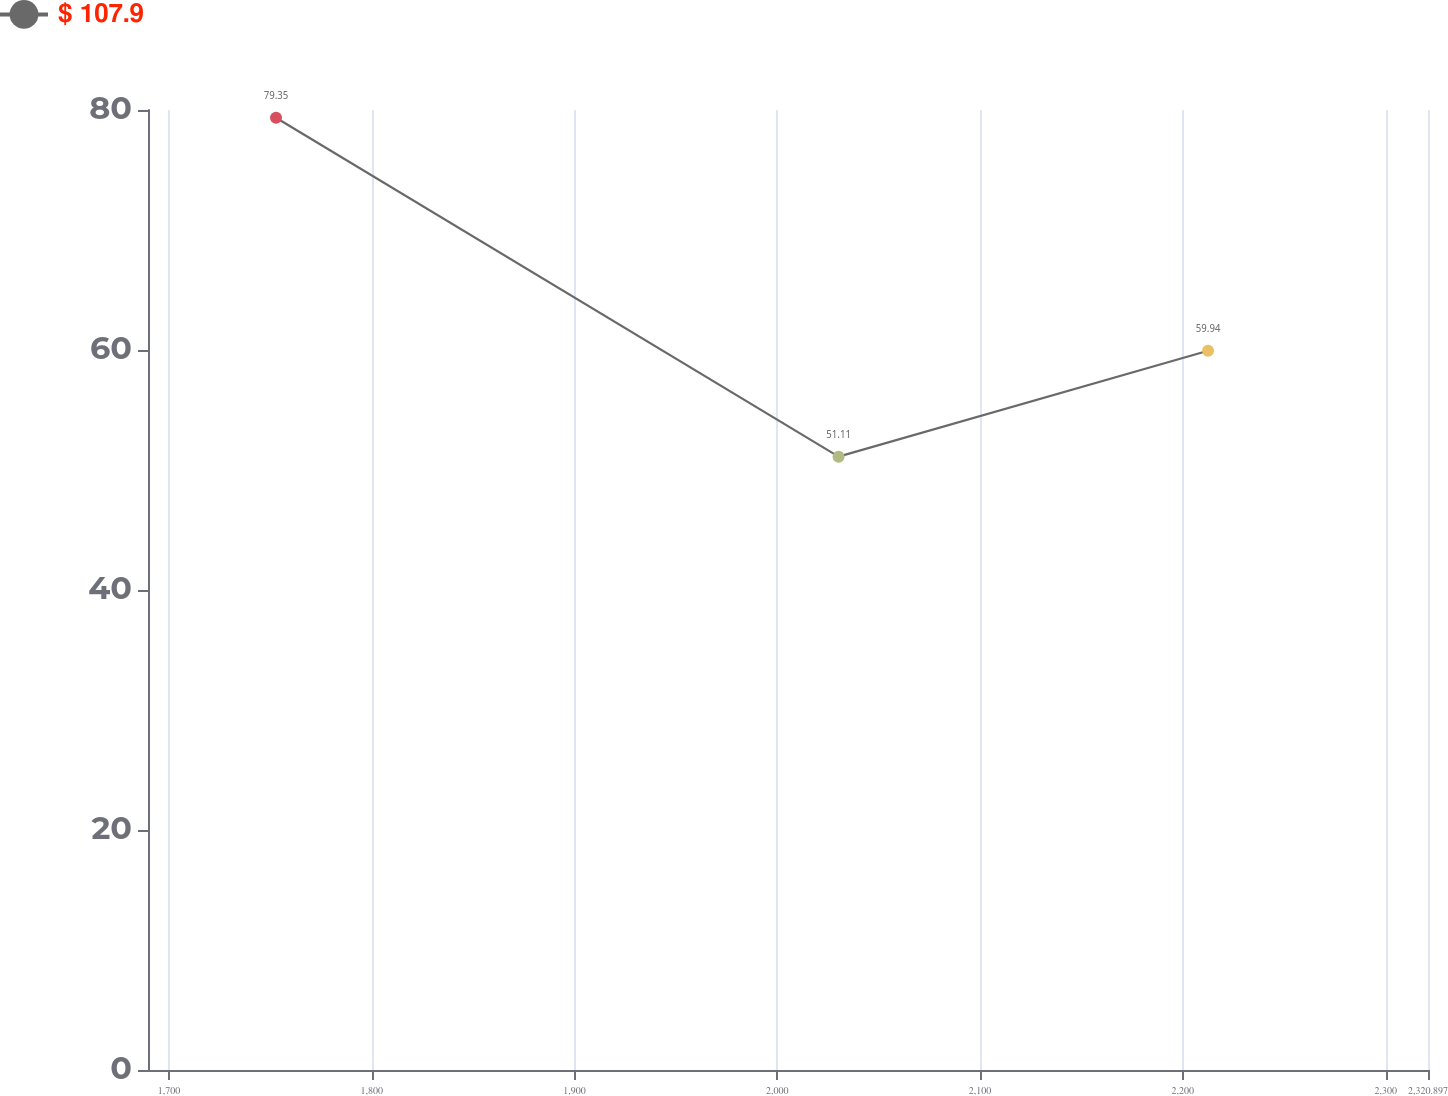<chart> <loc_0><loc_0><loc_500><loc_500><line_chart><ecel><fcel>$ 107.9<nl><fcel>1752.79<fcel>79.35<nl><fcel>2030.22<fcel>51.11<nl><fcel>2212.44<fcel>59.94<nl><fcel>2384.02<fcel>38.07<nl></chart> 